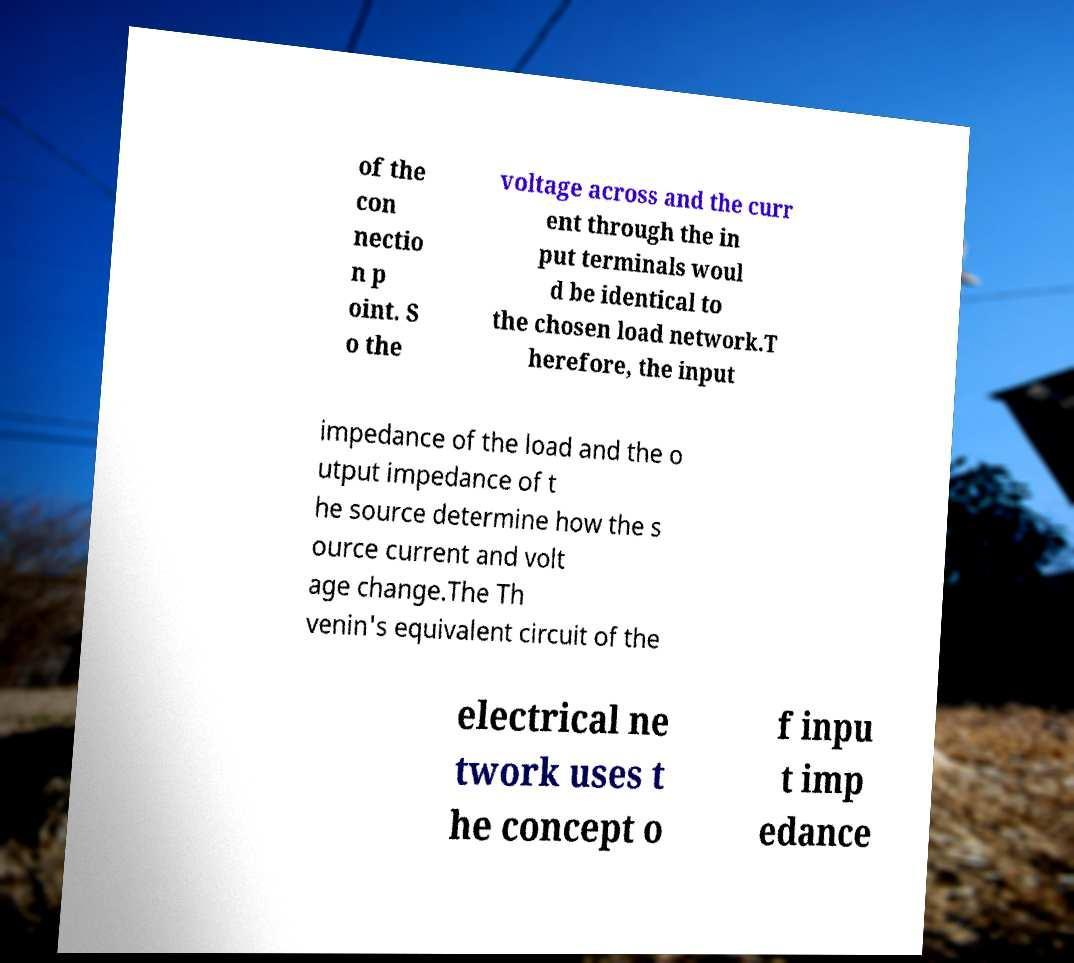What messages or text are displayed in this image? I need them in a readable, typed format. of the con nectio n p oint. S o the voltage across and the curr ent through the in put terminals woul d be identical to the chosen load network.T herefore, the input impedance of the load and the o utput impedance of t he source determine how the s ource current and volt age change.The Th venin's equivalent circuit of the electrical ne twork uses t he concept o f inpu t imp edance 